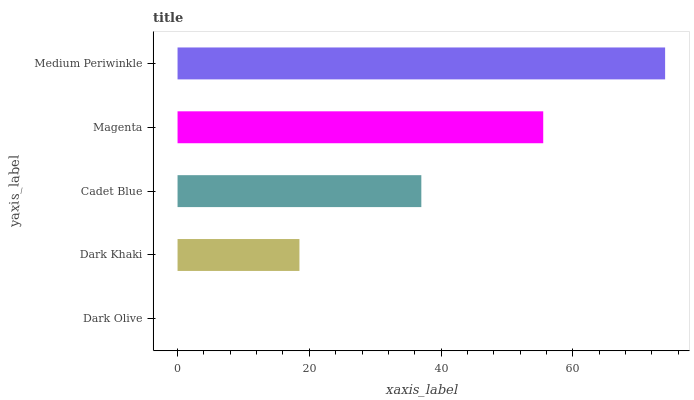Is Dark Olive the minimum?
Answer yes or no. Yes. Is Medium Periwinkle the maximum?
Answer yes or no. Yes. Is Dark Khaki the minimum?
Answer yes or no. No. Is Dark Khaki the maximum?
Answer yes or no. No. Is Dark Khaki greater than Dark Olive?
Answer yes or no. Yes. Is Dark Olive less than Dark Khaki?
Answer yes or no. Yes. Is Dark Olive greater than Dark Khaki?
Answer yes or no. No. Is Dark Khaki less than Dark Olive?
Answer yes or no. No. Is Cadet Blue the high median?
Answer yes or no. Yes. Is Cadet Blue the low median?
Answer yes or no. Yes. Is Medium Periwinkle the high median?
Answer yes or no. No. Is Dark Khaki the low median?
Answer yes or no. No. 